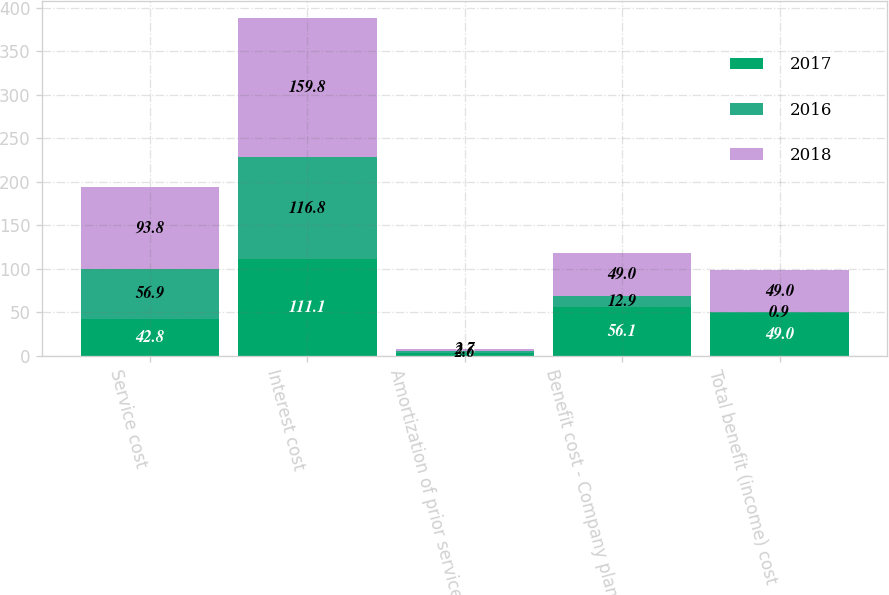Convert chart to OTSL. <chart><loc_0><loc_0><loc_500><loc_500><stacked_bar_chart><ecel><fcel>Service cost<fcel>Interest cost<fcel>Amortization of prior service<fcel>Benefit cost - Company plans<fcel>Total benefit (income) cost<nl><fcel>2017<fcel>42.8<fcel>111.1<fcel>2.9<fcel>56.1<fcel>49<nl><fcel>2016<fcel>56.9<fcel>116.8<fcel>2.6<fcel>12.9<fcel>0.9<nl><fcel>2018<fcel>93.8<fcel>159.8<fcel>2.7<fcel>49<fcel>49<nl></chart> 